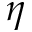<formula> <loc_0><loc_0><loc_500><loc_500>\eta</formula> 